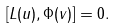<formula> <loc_0><loc_0><loc_500><loc_500>[ L ( u ) , \Phi ( v ) ] = 0 .</formula> 